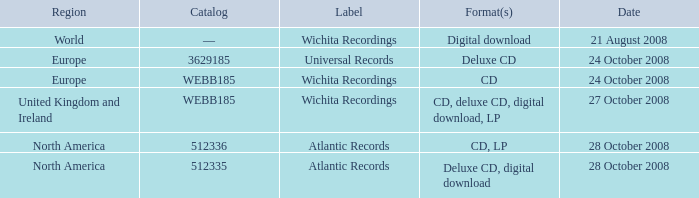Can you give me this table as a dict? {'header': ['Region', 'Catalog', 'Label', 'Format(s)', 'Date'], 'rows': [['World', '—', 'Wichita Recordings', 'Digital download', '21 August 2008'], ['Europe', '3629185', 'Universal Records', 'Deluxe CD', '24 October 2008'], ['Europe', 'WEBB185', 'Wichita Recordings', 'CD', '24 October 2008'], ['United Kingdom and Ireland', 'WEBB185', 'Wichita Recordings', 'CD, deluxe CD, digital download, LP', '27 October 2008'], ['North America', '512336', 'Atlantic Records', 'CD, LP', '28 October 2008'], ['North America', '512335', 'Atlantic Records', 'Deluxe CD, digital download', '28 October 2008']]} What are the formats associated with the Atlantic Records label, catalog number 512336? CD, LP. 